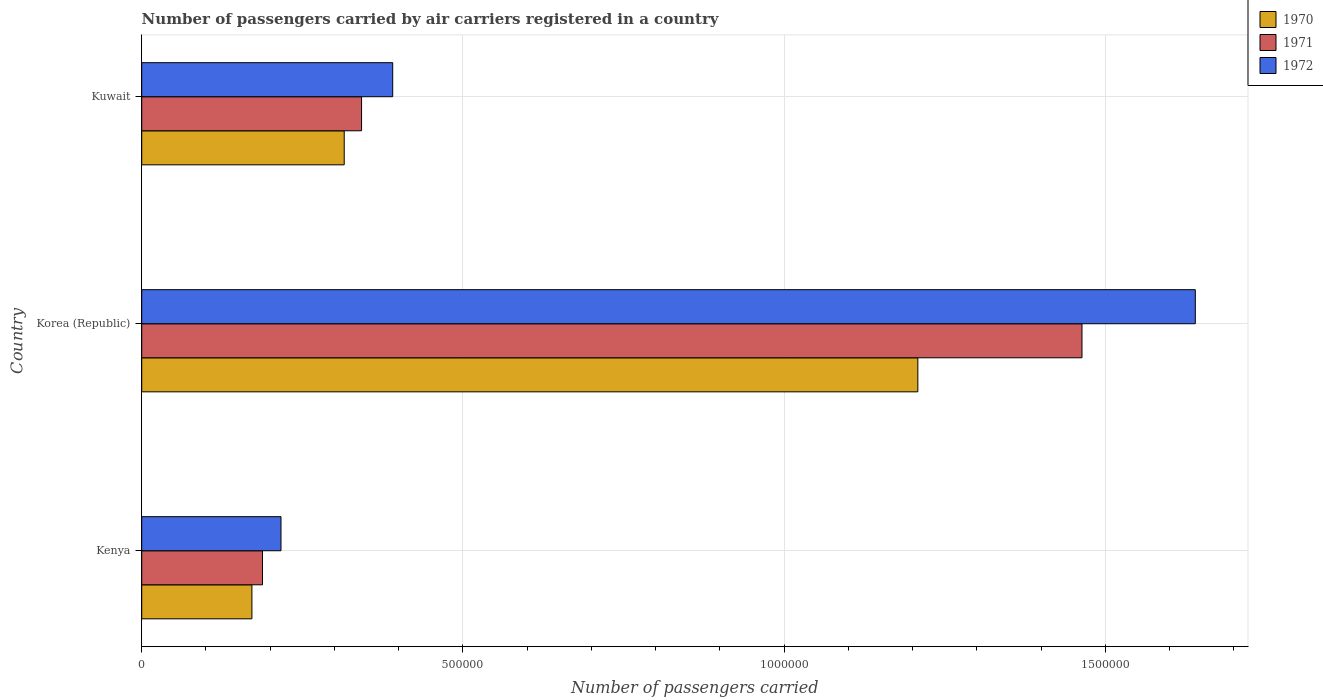How many groups of bars are there?
Make the answer very short. 3. Are the number of bars per tick equal to the number of legend labels?
Offer a terse response. Yes. How many bars are there on the 2nd tick from the top?
Keep it short and to the point. 3. How many bars are there on the 3rd tick from the bottom?
Your answer should be very brief. 3. What is the label of the 2nd group of bars from the top?
Offer a terse response. Korea (Republic). What is the number of passengers carried by air carriers in 1972 in Korea (Republic)?
Provide a succinct answer. 1.64e+06. Across all countries, what is the maximum number of passengers carried by air carriers in 1970?
Provide a succinct answer. 1.21e+06. Across all countries, what is the minimum number of passengers carried by air carriers in 1970?
Provide a short and direct response. 1.72e+05. In which country was the number of passengers carried by air carriers in 1970 minimum?
Make the answer very short. Kenya. What is the total number of passengers carried by air carriers in 1972 in the graph?
Keep it short and to the point. 2.25e+06. What is the difference between the number of passengers carried by air carriers in 1972 in Kenya and that in Korea (Republic)?
Provide a short and direct response. -1.42e+06. What is the difference between the number of passengers carried by air carriers in 1971 in Kenya and the number of passengers carried by air carriers in 1972 in Korea (Republic)?
Make the answer very short. -1.45e+06. What is the average number of passengers carried by air carriers in 1970 per country?
Provide a succinct answer. 5.65e+05. What is the difference between the number of passengers carried by air carriers in 1970 and number of passengers carried by air carriers in 1972 in Kenya?
Make the answer very short. -4.53e+04. In how many countries, is the number of passengers carried by air carriers in 1970 greater than 1200000 ?
Your answer should be very brief. 1. What is the ratio of the number of passengers carried by air carriers in 1970 in Korea (Republic) to that in Kuwait?
Offer a terse response. 3.83. What is the difference between the highest and the second highest number of passengers carried by air carriers in 1970?
Provide a short and direct response. 8.93e+05. What is the difference between the highest and the lowest number of passengers carried by air carriers in 1970?
Ensure brevity in your answer.  1.04e+06. In how many countries, is the number of passengers carried by air carriers in 1970 greater than the average number of passengers carried by air carriers in 1970 taken over all countries?
Your answer should be compact. 1. Is the sum of the number of passengers carried by air carriers in 1972 in Kenya and Kuwait greater than the maximum number of passengers carried by air carriers in 1971 across all countries?
Provide a short and direct response. No. What does the 3rd bar from the top in Kenya represents?
Your answer should be very brief. 1970. What does the 1st bar from the bottom in Kenya represents?
Make the answer very short. 1970. How many bars are there?
Give a very brief answer. 9. How many countries are there in the graph?
Offer a terse response. 3. What is the difference between two consecutive major ticks on the X-axis?
Offer a terse response. 5.00e+05. Are the values on the major ticks of X-axis written in scientific E-notation?
Provide a succinct answer. No. Does the graph contain any zero values?
Keep it short and to the point. No. Where does the legend appear in the graph?
Provide a short and direct response. Top right. How many legend labels are there?
Keep it short and to the point. 3. What is the title of the graph?
Your answer should be compact. Number of passengers carried by air carriers registered in a country. Does "1962" appear as one of the legend labels in the graph?
Your answer should be very brief. No. What is the label or title of the X-axis?
Offer a terse response. Number of passengers carried. What is the label or title of the Y-axis?
Your response must be concise. Country. What is the Number of passengers carried in 1970 in Kenya?
Offer a terse response. 1.72e+05. What is the Number of passengers carried in 1971 in Kenya?
Provide a succinct answer. 1.88e+05. What is the Number of passengers carried in 1972 in Kenya?
Keep it short and to the point. 2.17e+05. What is the Number of passengers carried in 1970 in Korea (Republic)?
Your answer should be compact. 1.21e+06. What is the Number of passengers carried in 1971 in Korea (Republic)?
Offer a very short reply. 1.46e+06. What is the Number of passengers carried in 1972 in Korea (Republic)?
Provide a succinct answer. 1.64e+06. What is the Number of passengers carried of 1970 in Kuwait?
Offer a terse response. 3.15e+05. What is the Number of passengers carried of 1971 in Kuwait?
Offer a very short reply. 3.42e+05. What is the Number of passengers carried of 1972 in Kuwait?
Your response must be concise. 3.91e+05. Across all countries, what is the maximum Number of passengers carried of 1970?
Make the answer very short. 1.21e+06. Across all countries, what is the maximum Number of passengers carried of 1971?
Your response must be concise. 1.46e+06. Across all countries, what is the maximum Number of passengers carried in 1972?
Your response must be concise. 1.64e+06. Across all countries, what is the minimum Number of passengers carried in 1970?
Your answer should be compact. 1.72e+05. Across all countries, what is the minimum Number of passengers carried in 1971?
Your answer should be very brief. 1.88e+05. Across all countries, what is the minimum Number of passengers carried of 1972?
Provide a short and direct response. 2.17e+05. What is the total Number of passengers carried of 1970 in the graph?
Ensure brevity in your answer.  1.69e+06. What is the total Number of passengers carried in 1971 in the graph?
Ensure brevity in your answer.  1.99e+06. What is the total Number of passengers carried of 1972 in the graph?
Make the answer very short. 2.25e+06. What is the difference between the Number of passengers carried in 1970 in Kenya and that in Korea (Republic)?
Make the answer very short. -1.04e+06. What is the difference between the Number of passengers carried in 1971 in Kenya and that in Korea (Republic)?
Your answer should be very brief. -1.28e+06. What is the difference between the Number of passengers carried in 1972 in Kenya and that in Korea (Republic)?
Ensure brevity in your answer.  -1.42e+06. What is the difference between the Number of passengers carried of 1970 in Kenya and that in Kuwait?
Make the answer very short. -1.44e+05. What is the difference between the Number of passengers carried of 1971 in Kenya and that in Kuwait?
Ensure brevity in your answer.  -1.54e+05. What is the difference between the Number of passengers carried in 1972 in Kenya and that in Kuwait?
Give a very brief answer. -1.74e+05. What is the difference between the Number of passengers carried of 1970 in Korea (Republic) and that in Kuwait?
Make the answer very short. 8.93e+05. What is the difference between the Number of passengers carried in 1971 in Korea (Republic) and that in Kuwait?
Provide a short and direct response. 1.12e+06. What is the difference between the Number of passengers carried of 1972 in Korea (Republic) and that in Kuwait?
Offer a very short reply. 1.25e+06. What is the difference between the Number of passengers carried of 1970 in Kenya and the Number of passengers carried of 1971 in Korea (Republic)?
Make the answer very short. -1.29e+06. What is the difference between the Number of passengers carried of 1970 in Kenya and the Number of passengers carried of 1972 in Korea (Republic)?
Your answer should be very brief. -1.47e+06. What is the difference between the Number of passengers carried of 1971 in Kenya and the Number of passengers carried of 1972 in Korea (Republic)?
Provide a succinct answer. -1.45e+06. What is the difference between the Number of passengers carried of 1970 in Kenya and the Number of passengers carried of 1971 in Kuwait?
Your response must be concise. -1.71e+05. What is the difference between the Number of passengers carried in 1970 in Kenya and the Number of passengers carried in 1972 in Kuwait?
Provide a succinct answer. -2.19e+05. What is the difference between the Number of passengers carried in 1971 in Kenya and the Number of passengers carried in 1972 in Kuwait?
Provide a short and direct response. -2.03e+05. What is the difference between the Number of passengers carried in 1970 in Korea (Republic) and the Number of passengers carried in 1971 in Kuwait?
Provide a succinct answer. 8.66e+05. What is the difference between the Number of passengers carried in 1970 in Korea (Republic) and the Number of passengers carried in 1972 in Kuwait?
Provide a short and direct response. 8.17e+05. What is the difference between the Number of passengers carried of 1971 in Korea (Republic) and the Number of passengers carried of 1972 in Kuwait?
Your answer should be very brief. 1.07e+06. What is the average Number of passengers carried in 1970 per country?
Provide a succinct answer. 5.65e+05. What is the average Number of passengers carried of 1971 per country?
Your answer should be very brief. 6.65e+05. What is the average Number of passengers carried of 1972 per country?
Your answer should be very brief. 7.49e+05. What is the difference between the Number of passengers carried in 1970 and Number of passengers carried in 1971 in Kenya?
Provide a short and direct response. -1.65e+04. What is the difference between the Number of passengers carried in 1970 and Number of passengers carried in 1972 in Kenya?
Ensure brevity in your answer.  -4.53e+04. What is the difference between the Number of passengers carried in 1971 and Number of passengers carried in 1972 in Kenya?
Your answer should be very brief. -2.88e+04. What is the difference between the Number of passengers carried of 1970 and Number of passengers carried of 1971 in Korea (Republic)?
Provide a succinct answer. -2.56e+05. What is the difference between the Number of passengers carried in 1970 and Number of passengers carried in 1972 in Korea (Republic)?
Provide a short and direct response. -4.32e+05. What is the difference between the Number of passengers carried in 1971 and Number of passengers carried in 1972 in Korea (Republic)?
Ensure brevity in your answer.  -1.76e+05. What is the difference between the Number of passengers carried in 1970 and Number of passengers carried in 1971 in Kuwait?
Give a very brief answer. -2.70e+04. What is the difference between the Number of passengers carried in 1970 and Number of passengers carried in 1972 in Kuwait?
Provide a short and direct response. -7.55e+04. What is the difference between the Number of passengers carried of 1971 and Number of passengers carried of 1972 in Kuwait?
Your answer should be compact. -4.85e+04. What is the ratio of the Number of passengers carried of 1970 in Kenya to that in Korea (Republic)?
Your response must be concise. 0.14. What is the ratio of the Number of passengers carried in 1971 in Kenya to that in Korea (Republic)?
Give a very brief answer. 0.13. What is the ratio of the Number of passengers carried in 1972 in Kenya to that in Korea (Republic)?
Provide a short and direct response. 0.13. What is the ratio of the Number of passengers carried in 1970 in Kenya to that in Kuwait?
Provide a short and direct response. 0.54. What is the ratio of the Number of passengers carried of 1971 in Kenya to that in Kuwait?
Make the answer very short. 0.55. What is the ratio of the Number of passengers carried of 1972 in Kenya to that in Kuwait?
Make the answer very short. 0.55. What is the ratio of the Number of passengers carried in 1970 in Korea (Republic) to that in Kuwait?
Offer a terse response. 3.83. What is the ratio of the Number of passengers carried in 1971 in Korea (Republic) to that in Kuwait?
Your answer should be compact. 4.28. What is the ratio of the Number of passengers carried in 1972 in Korea (Republic) to that in Kuwait?
Your answer should be compact. 4.2. What is the difference between the highest and the second highest Number of passengers carried in 1970?
Your answer should be very brief. 8.93e+05. What is the difference between the highest and the second highest Number of passengers carried of 1971?
Offer a very short reply. 1.12e+06. What is the difference between the highest and the second highest Number of passengers carried of 1972?
Your response must be concise. 1.25e+06. What is the difference between the highest and the lowest Number of passengers carried in 1970?
Give a very brief answer. 1.04e+06. What is the difference between the highest and the lowest Number of passengers carried of 1971?
Your answer should be very brief. 1.28e+06. What is the difference between the highest and the lowest Number of passengers carried of 1972?
Give a very brief answer. 1.42e+06. 